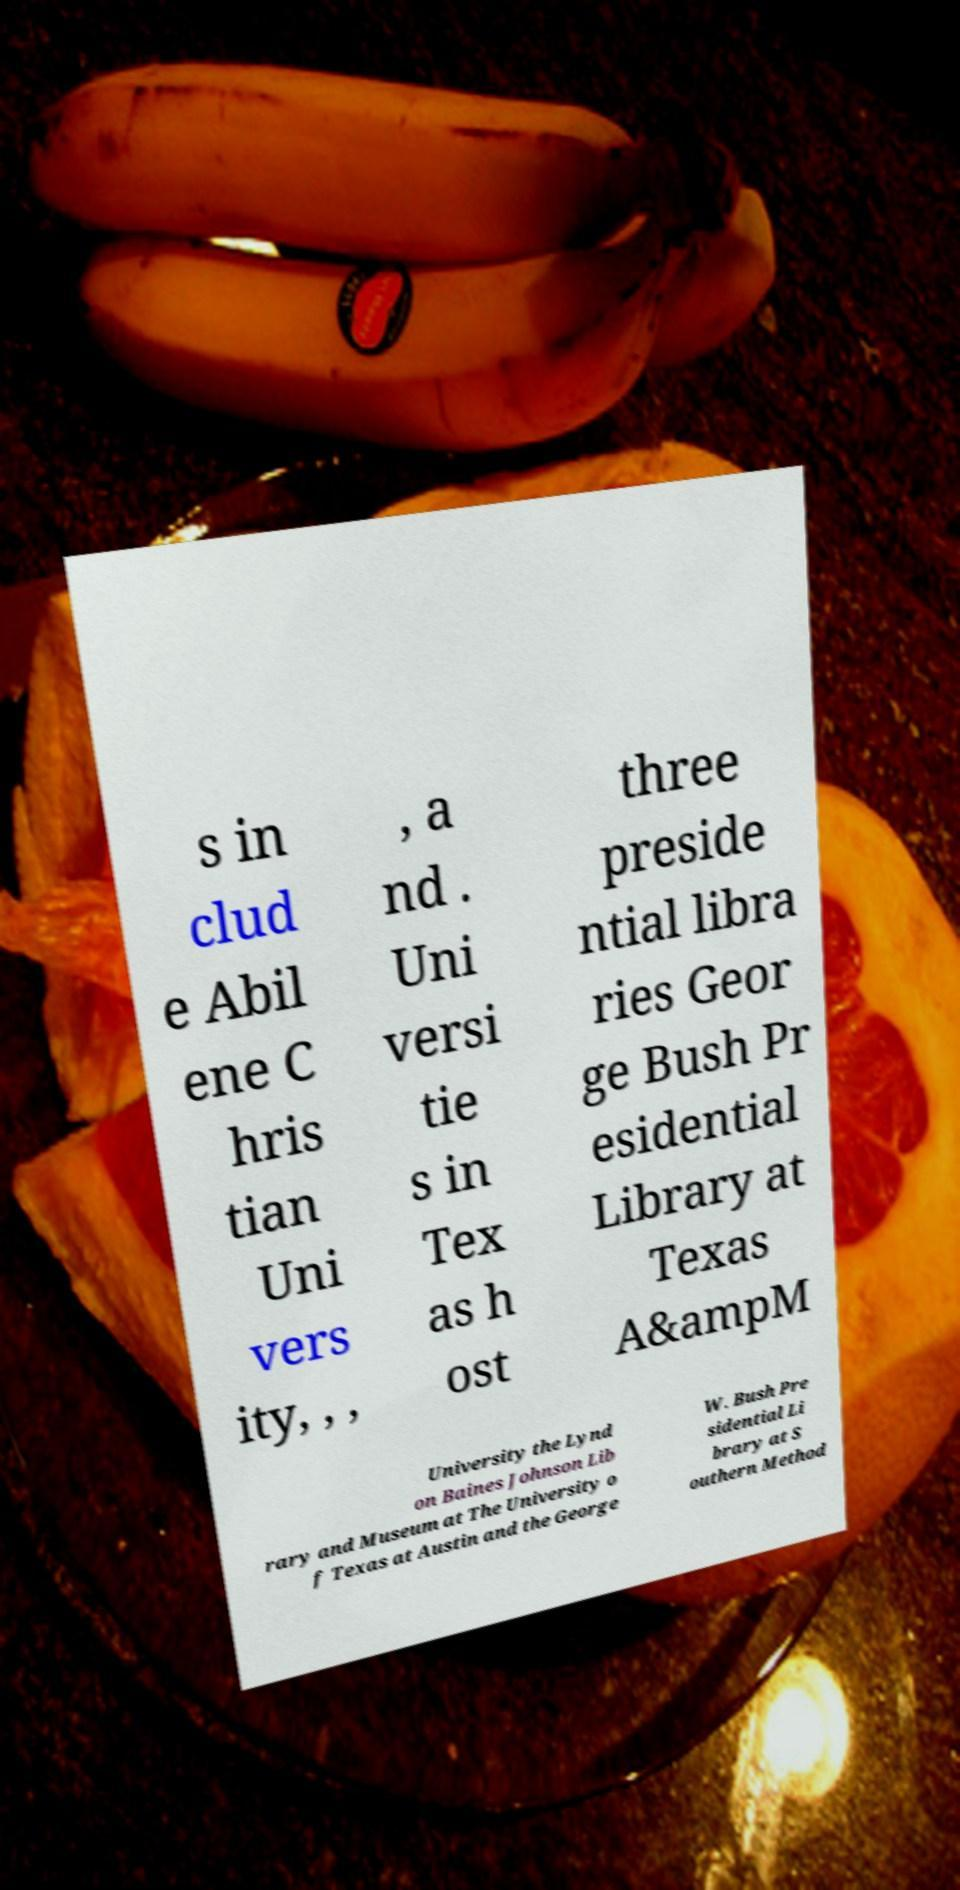Can you accurately transcribe the text from the provided image for me? s in clud e Abil ene C hris tian Uni vers ity, , , , a nd . Uni versi tie s in Tex as h ost three preside ntial libra ries Geor ge Bush Pr esidential Library at Texas A&ampM University the Lynd on Baines Johnson Lib rary and Museum at The University o f Texas at Austin and the George W. Bush Pre sidential Li brary at S outhern Method 